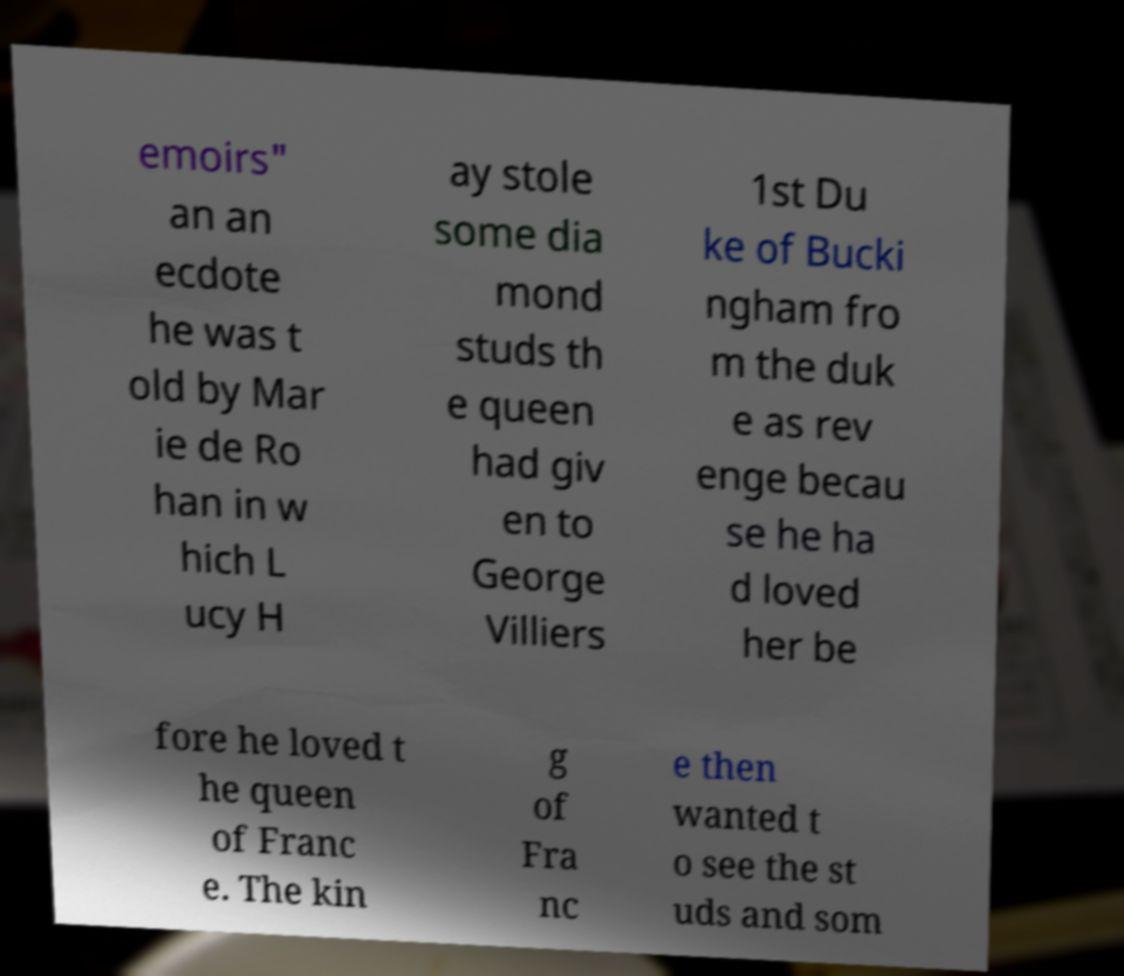Could you extract and type out the text from this image? emoirs" an an ecdote he was t old by Mar ie de Ro han in w hich L ucy H ay stole some dia mond studs th e queen had giv en to George Villiers 1st Du ke of Bucki ngham fro m the duk e as rev enge becau se he ha d loved her be fore he loved t he queen of Franc e. The kin g of Fra nc e then wanted t o see the st uds and som 